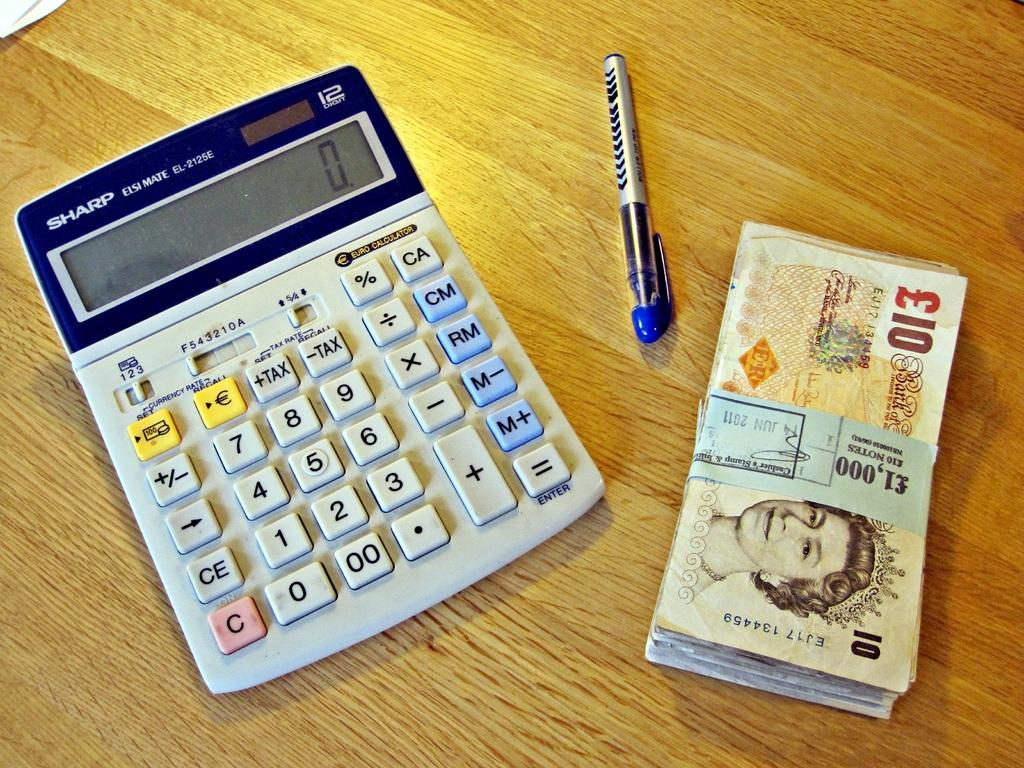<image>
Render a clear and concise summary of the photo. A calculator with zero on the screen next to a stack of bills with a women on them. 